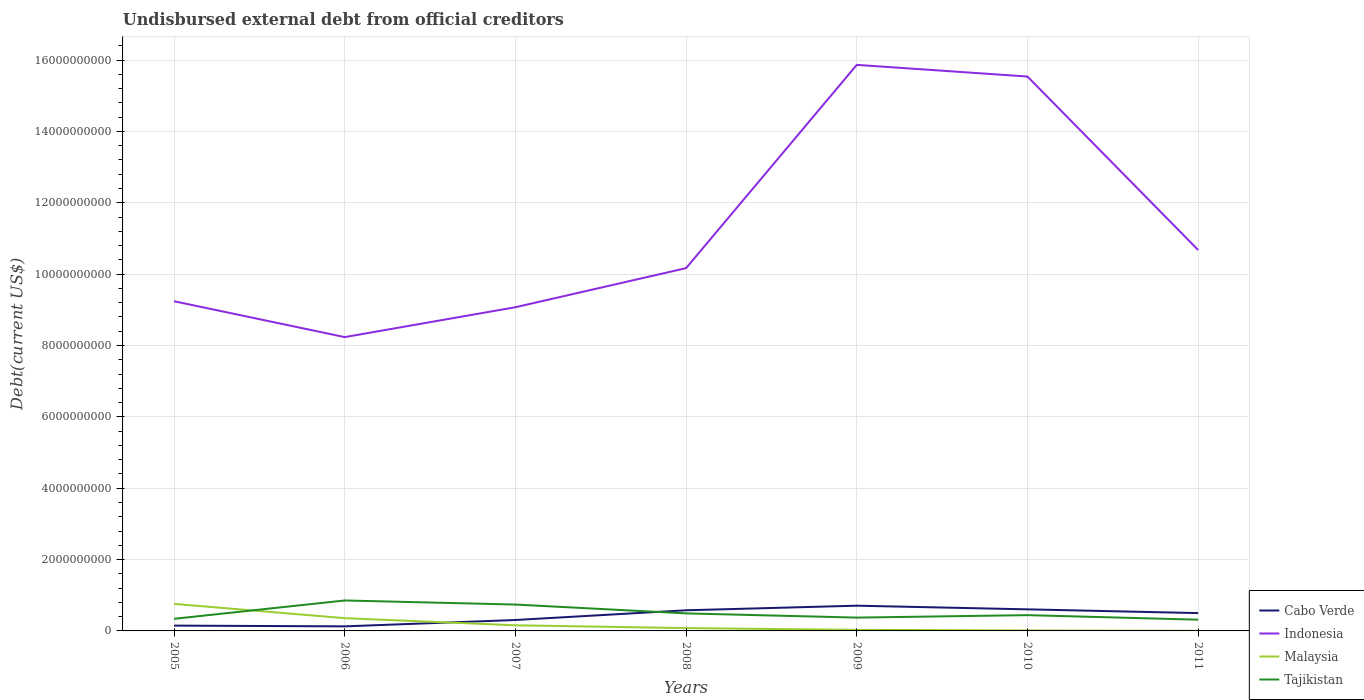How many different coloured lines are there?
Ensure brevity in your answer.  4. Does the line corresponding to Malaysia intersect with the line corresponding to Indonesia?
Offer a very short reply. No. Is the number of lines equal to the number of legend labels?
Provide a short and direct response. Yes. Across all years, what is the maximum total debt in Cabo Verde?
Offer a terse response. 1.28e+08. In which year was the total debt in Indonesia maximum?
Give a very brief answer. 2006. What is the total total debt in Indonesia in the graph?
Provide a succinct answer. -1.10e+09. What is the difference between the highest and the second highest total debt in Malaysia?
Your answer should be compact. 7.54e+08. What is the difference between two consecutive major ticks on the Y-axis?
Give a very brief answer. 2.00e+09. Where does the legend appear in the graph?
Keep it short and to the point. Bottom right. What is the title of the graph?
Your answer should be very brief. Undisbursed external debt from official creditors. Does "Senegal" appear as one of the legend labels in the graph?
Your answer should be compact. No. What is the label or title of the X-axis?
Offer a terse response. Years. What is the label or title of the Y-axis?
Your response must be concise. Debt(current US$). What is the Debt(current US$) in Cabo Verde in 2005?
Your response must be concise. 1.49e+08. What is the Debt(current US$) in Indonesia in 2005?
Your answer should be compact. 9.24e+09. What is the Debt(current US$) in Malaysia in 2005?
Your answer should be very brief. 7.57e+08. What is the Debt(current US$) in Tajikistan in 2005?
Your response must be concise. 3.39e+08. What is the Debt(current US$) in Cabo Verde in 2006?
Offer a terse response. 1.28e+08. What is the Debt(current US$) of Indonesia in 2006?
Offer a terse response. 8.23e+09. What is the Debt(current US$) of Malaysia in 2006?
Keep it short and to the point. 3.57e+08. What is the Debt(current US$) of Tajikistan in 2006?
Make the answer very short. 8.53e+08. What is the Debt(current US$) in Cabo Verde in 2007?
Offer a terse response. 3.06e+08. What is the Debt(current US$) of Indonesia in 2007?
Give a very brief answer. 9.07e+09. What is the Debt(current US$) of Malaysia in 2007?
Make the answer very short. 1.58e+08. What is the Debt(current US$) of Tajikistan in 2007?
Your response must be concise. 7.39e+08. What is the Debt(current US$) of Cabo Verde in 2008?
Your answer should be compact. 5.79e+08. What is the Debt(current US$) in Indonesia in 2008?
Your response must be concise. 1.02e+1. What is the Debt(current US$) of Malaysia in 2008?
Keep it short and to the point. 7.89e+07. What is the Debt(current US$) in Tajikistan in 2008?
Your answer should be very brief. 4.91e+08. What is the Debt(current US$) of Cabo Verde in 2009?
Give a very brief answer. 7.07e+08. What is the Debt(current US$) of Indonesia in 2009?
Provide a succinct answer. 1.59e+1. What is the Debt(current US$) in Malaysia in 2009?
Your answer should be compact. 3.03e+07. What is the Debt(current US$) of Tajikistan in 2009?
Give a very brief answer. 3.73e+08. What is the Debt(current US$) of Cabo Verde in 2010?
Make the answer very short. 6.05e+08. What is the Debt(current US$) in Indonesia in 2010?
Your answer should be very brief. 1.55e+1. What is the Debt(current US$) of Malaysia in 2010?
Your answer should be very brief. 1.37e+07. What is the Debt(current US$) of Tajikistan in 2010?
Give a very brief answer. 4.42e+08. What is the Debt(current US$) of Cabo Verde in 2011?
Keep it short and to the point. 5.00e+08. What is the Debt(current US$) of Indonesia in 2011?
Keep it short and to the point. 1.07e+1. What is the Debt(current US$) of Malaysia in 2011?
Your answer should be very brief. 3.48e+06. What is the Debt(current US$) of Tajikistan in 2011?
Give a very brief answer. 3.15e+08. Across all years, what is the maximum Debt(current US$) in Cabo Verde?
Your response must be concise. 7.07e+08. Across all years, what is the maximum Debt(current US$) of Indonesia?
Make the answer very short. 1.59e+1. Across all years, what is the maximum Debt(current US$) of Malaysia?
Make the answer very short. 7.57e+08. Across all years, what is the maximum Debt(current US$) in Tajikistan?
Offer a terse response. 8.53e+08. Across all years, what is the minimum Debt(current US$) of Cabo Verde?
Offer a very short reply. 1.28e+08. Across all years, what is the minimum Debt(current US$) of Indonesia?
Give a very brief answer. 8.23e+09. Across all years, what is the minimum Debt(current US$) of Malaysia?
Provide a short and direct response. 3.48e+06. Across all years, what is the minimum Debt(current US$) of Tajikistan?
Ensure brevity in your answer.  3.15e+08. What is the total Debt(current US$) in Cabo Verde in the graph?
Ensure brevity in your answer.  2.97e+09. What is the total Debt(current US$) in Indonesia in the graph?
Ensure brevity in your answer.  7.88e+1. What is the total Debt(current US$) of Malaysia in the graph?
Offer a very short reply. 1.40e+09. What is the total Debt(current US$) in Tajikistan in the graph?
Keep it short and to the point. 3.55e+09. What is the difference between the Debt(current US$) in Cabo Verde in 2005 and that in 2006?
Your answer should be compact. 2.10e+07. What is the difference between the Debt(current US$) of Indonesia in 2005 and that in 2006?
Offer a terse response. 1.01e+09. What is the difference between the Debt(current US$) of Malaysia in 2005 and that in 2006?
Offer a terse response. 4.00e+08. What is the difference between the Debt(current US$) in Tajikistan in 2005 and that in 2006?
Ensure brevity in your answer.  -5.14e+08. What is the difference between the Debt(current US$) in Cabo Verde in 2005 and that in 2007?
Your answer should be compact. -1.58e+08. What is the difference between the Debt(current US$) of Indonesia in 2005 and that in 2007?
Your answer should be very brief. 1.68e+08. What is the difference between the Debt(current US$) of Malaysia in 2005 and that in 2007?
Provide a short and direct response. 6.00e+08. What is the difference between the Debt(current US$) of Tajikistan in 2005 and that in 2007?
Provide a short and direct response. -4.00e+08. What is the difference between the Debt(current US$) of Cabo Verde in 2005 and that in 2008?
Your answer should be very brief. -4.30e+08. What is the difference between the Debt(current US$) of Indonesia in 2005 and that in 2008?
Provide a succinct answer. -9.28e+08. What is the difference between the Debt(current US$) of Malaysia in 2005 and that in 2008?
Keep it short and to the point. 6.79e+08. What is the difference between the Debt(current US$) of Tajikistan in 2005 and that in 2008?
Provide a succinct answer. -1.52e+08. What is the difference between the Debt(current US$) in Cabo Verde in 2005 and that in 2009?
Offer a very short reply. -5.58e+08. What is the difference between the Debt(current US$) of Indonesia in 2005 and that in 2009?
Make the answer very short. -6.62e+09. What is the difference between the Debt(current US$) in Malaysia in 2005 and that in 2009?
Give a very brief answer. 7.27e+08. What is the difference between the Debt(current US$) in Tajikistan in 2005 and that in 2009?
Keep it short and to the point. -3.41e+07. What is the difference between the Debt(current US$) in Cabo Verde in 2005 and that in 2010?
Make the answer very short. -4.56e+08. What is the difference between the Debt(current US$) of Indonesia in 2005 and that in 2010?
Provide a succinct answer. -6.30e+09. What is the difference between the Debt(current US$) of Malaysia in 2005 and that in 2010?
Ensure brevity in your answer.  7.44e+08. What is the difference between the Debt(current US$) of Tajikistan in 2005 and that in 2010?
Your answer should be compact. -1.03e+08. What is the difference between the Debt(current US$) of Cabo Verde in 2005 and that in 2011?
Give a very brief answer. -3.51e+08. What is the difference between the Debt(current US$) in Indonesia in 2005 and that in 2011?
Offer a very short reply. -1.44e+09. What is the difference between the Debt(current US$) of Malaysia in 2005 and that in 2011?
Your response must be concise. 7.54e+08. What is the difference between the Debt(current US$) of Tajikistan in 2005 and that in 2011?
Provide a short and direct response. 2.46e+07. What is the difference between the Debt(current US$) of Cabo Verde in 2006 and that in 2007?
Keep it short and to the point. -1.79e+08. What is the difference between the Debt(current US$) of Indonesia in 2006 and that in 2007?
Your answer should be compact. -8.38e+08. What is the difference between the Debt(current US$) of Malaysia in 2006 and that in 2007?
Provide a succinct answer. 2.00e+08. What is the difference between the Debt(current US$) in Tajikistan in 2006 and that in 2007?
Your answer should be compact. 1.14e+08. What is the difference between the Debt(current US$) in Cabo Verde in 2006 and that in 2008?
Make the answer very short. -4.51e+08. What is the difference between the Debt(current US$) in Indonesia in 2006 and that in 2008?
Provide a succinct answer. -1.93e+09. What is the difference between the Debt(current US$) in Malaysia in 2006 and that in 2008?
Give a very brief answer. 2.78e+08. What is the difference between the Debt(current US$) in Tajikistan in 2006 and that in 2008?
Provide a short and direct response. 3.62e+08. What is the difference between the Debt(current US$) in Cabo Verde in 2006 and that in 2009?
Provide a short and direct response. -5.79e+08. What is the difference between the Debt(current US$) in Indonesia in 2006 and that in 2009?
Provide a succinct answer. -7.63e+09. What is the difference between the Debt(current US$) of Malaysia in 2006 and that in 2009?
Your response must be concise. 3.27e+08. What is the difference between the Debt(current US$) in Tajikistan in 2006 and that in 2009?
Give a very brief answer. 4.80e+08. What is the difference between the Debt(current US$) of Cabo Verde in 2006 and that in 2010?
Keep it short and to the point. -4.77e+08. What is the difference between the Debt(current US$) in Indonesia in 2006 and that in 2010?
Make the answer very short. -7.30e+09. What is the difference between the Debt(current US$) in Malaysia in 2006 and that in 2010?
Offer a very short reply. 3.44e+08. What is the difference between the Debt(current US$) in Tajikistan in 2006 and that in 2010?
Give a very brief answer. 4.11e+08. What is the difference between the Debt(current US$) in Cabo Verde in 2006 and that in 2011?
Ensure brevity in your answer.  -3.72e+08. What is the difference between the Debt(current US$) of Indonesia in 2006 and that in 2011?
Provide a succinct answer. -2.44e+09. What is the difference between the Debt(current US$) in Malaysia in 2006 and that in 2011?
Ensure brevity in your answer.  3.54e+08. What is the difference between the Debt(current US$) of Tajikistan in 2006 and that in 2011?
Your answer should be compact. 5.39e+08. What is the difference between the Debt(current US$) in Cabo Verde in 2007 and that in 2008?
Offer a terse response. -2.72e+08. What is the difference between the Debt(current US$) in Indonesia in 2007 and that in 2008?
Provide a succinct answer. -1.10e+09. What is the difference between the Debt(current US$) in Malaysia in 2007 and that in 2008?
Ensure brevity in your answer.  7.87e+07. What is the difference between the Debt(current US$) in Tajikistan in 2007 and that in 2008?
Your response must be concise. 2.48e+08. What is the difference between the Debt(current US$) of Cabo Verde in 2007 and that in 2009?
Ensure brevity in your answer.  -4.01e+08. What is the difference between the Debt(current US$) of Indonesia in 2007 and that in 2009?
Ensure brevity in your answer.  -6.79e+09. What is the difference between the Debt(current US$) in Malaysia in 2007 and that in 2009?
Keep it short and to the point. 1.27e+08. What is the difference between the Debt(current US$) in Tajikistan in 2007 and that in 2009?
Offer a terse response. 3.66e+08. What is the difference between the Debt(current US$) in Cabo Verde in 2007 and that in 2010?
Provide a succinct answer. -2.98e+08. What is the difference between the Debt(current US$) in Indonesia in 2007 and that in 2010?
Offer a very short reply. -6.47e+09. What is the difference between the Debt(current US$) in Malaysia in 2007 and that in 2010?
Give a very brief answer. 1.44e+08. What is the difference between the Debt(current US$) in Tajikistan in 2007 and that in 2010?
Make the answer very short. 2.97e+08. What is the difference between the Debt(current US$) in Cabo Verde in 2007 and that in 2011?
Provide a succinct answer. -1.94e+08. What is the difference between the Debt(current US$) of Indonesia in 2007 and that in 2011?
Offer a terse response. -1.60e+09. What is the difference between the Debt(current US$) in Malaysia in 2007 and that in 2011?
Offer a very short reply. 1.54e+08. What is the difference between the Debt(current US$) of Tajikistan in 2007 and that in 2011?
Offer a terse response. 4.24e+08. What is the difference between the Debt(current US$) in Cabo Verde in 2008 and that in 2009?
Your response must be concise. -1.29e+08. What is the difference between the Debt(current US$) in Indonesia in 2008 and that in 2009?
Offer a terse response. -5.70e+09. What is the difference between the Debt(current US$) of Malaysia in 2008 and that in 2009?
Offer a terse response. 4.86e+07. What is the difference between the Debt(current US$) in Tajikistan in 2008 and that in 2009?
Your answer should be compact. 1.18e+08. What is the difference between the Debt(current US$) of Cabo Verde in 2008 and that in 2010?
Offer a terse response. -2.62e+07. What is the difference between the Debt(current US$) of Indonesia in 2008 and that in 2010?
Provide a short and direct response. -5.37e+09. What is the difference between the Debt(current US$) in Malaysia in 2008 and that in 2010?
Your answer should be very brief. 6.52e+07. What is the difference between the Debt(current US$) of Tajikistan in 2008 and that in 2010?
Your response must be concise. 4.91e+07. What is the difference between the Debt(current US$) in Cabo Verde in 2008 and that in 2011?
Provide a short and direct response. 7.88e+07. What is the difference between the Debt(current US$) in Indonesia in 2008 and that in 2011?
Make the answer very short. -5.10e+08. What is the difference between the Debt(current US$) in Malaysia in 2008 and that in 2011?
Ensure brevity in your answer.  7.54e+07. What is the difference between the Debt(current US$) of Tajikistan in 2008 and that in 2011?
Give a very brief answer. 1.77e+08. What is the difference between the Debt(current US$) in Cabo Verde in 2009 and that in 2010?
Your answer should be compact. 1.02e+08. What is the difference between the Debt(current US$) in Indonesia in 2009 and that in 2010?
Ensure brevity in your answer.  3.27e+08. What is the difference between the Debt(current US$) of Malaysia in 2009 and that in 2010?
Your answer should be very brief. 1.66e+07. What is the difference between the Debt(current US$) of Tajikistan in 2009 and that in 2010?
Your response must be concise. -6.88e+07. What is the difference between the Debt(current US$) in Cabo Verde in 2009 and that in 2011?
Your response must be concise. 2.07e+08. What is the difference between the Debt(current US$) in Indonesia in 2009 and that in 2011?
Provide a succinct answer. 5.19e+09. What is the difference between the Debt(current US$) of Malaysia in 2009 and that in 2011?
Provide a succinct answer. 2.68e+07. What is the difference between the Debt(current US$) of Tajikistan in 2009 and that in 2011?
Ensure brevity in your answer.  5.87e+07. What is the difference between the Debt(current US$) in Cabo Verde in 2010 and that in 2011?
Your response must be concise. 1.05e+08. What is the difference between the Debt(current US$) in Indonesia in 2010 and that in 2011?
Your response must be concise. 4.86e+09. What is the difference between the Debt(current US$) of Malaysia in 2010 and that in 2011?
Offer a terse response. 1.02e+07. What is the difference between the Debt(current US$) in Tajikistan in 2010 and that in 2011?
Make the answer very short. 1.27e+08. What is the difference between the Debt(current US$) of Cabo Verde in 2005 and the Debt(current US$) of Indonesia in 2006?
Your answer should be very brief. -8.09e+09. What is the difference between the Debt(current US$) of Cabo Verde in 2005 and the Debt(current US$) of Malaysia in 2006?
Provide a succinct answer. -2.09e+08. What is the difference between the Debt(current US$) in Cabo Verde in 2005 and the Debt(current US$) in Tajikistan in 2006?
Offer a terse response. -7.05e+08. What is the difference between the Debt(current US$) in Indonesia in 2005 and the Debt(current US$) in Malaysia in 2006?
Make the answer very short. 8.88e+09. What is the difference between the Debt(current US$) of Indonesia in 2005 and the Debt(current US$) of Tajikistan in 2006?
Ensure brevity in your answer.  8.39e+09. What is the difference between the Debt(current US$) in Malaysia in 2005 and the Debt(current US$) in Tajikistan in 2006?
Offer a terse response. -9.59e+07. What is the difference between the Debt(current US$) of Cabo Verde in 2005 and the Debt(current US$) of Indonesia in 2007?
Your response must be concise. -8.92e+09. What is the difference between the Debt(current US$) in Cabo Verde in 2005 and the Debt(current US$) in Malaysia in 2007?
Make the answer very short. -8.94e+06. What is the difference between the Debt(current US$) of Cabo Verde in 2005 and the Debt(current US$) of Tajikistan in 2007?
Provide a short and direct response. -5.90e+08. What is the difference between the Debt(current US$) of Indonesia in 2005 and the Debt(current US$) of Malaysia in 2007?
Offer a terse response. 9.08e+09. What is the difference between the Debt(current US$) in Indonesia in 2005 and the Debt(current US$) in Tajikistan in 2007?
Make the answer very short. 8.50e+09. What is the difference between the Debt(current US$) of Malaysia in 2005 and the Debt(current US$) of Tajikistan in 2007?
Your response must be concise. 1.83e+07. What is the difference between the Debt(current US$) of Cabo Verde in 2005 and the Debt(current US$) of Indonesia in 2008?
Offer a very short reply. -1.00e+1. What is the difference between the Debt(current US$) in Cabo Verde in 2005 and the Debt(current US$) in Malaysia in 2008?
Give a very brief answer. 6.98e+07. What is the difference between the Debt(current US$) of Cabo Verde in 2005 and the Debt(current US$) of Tajikistan in 2008?
Offer a very short reply. -3.43e+08. What is the difference between the Debt(current US$) in Indonesia in 2005 and the Debt(current US$) in Malaysia in 2008?
Provide a succinct answer. 9.16e+09. What is the difference between the Debt(current US$) in Indonesia in 2005 and the Debt(current US$) in Tajikistan in 2008?
Offer a terse response. 8.75e+09. What is the difference between the Debt(current US$) of Malaysia in 2005 and the Debt(current US$) of Tajikistan in 2008?
Provide a succinct answer. 2.66e+08. What is the difference between the Debt(current US$) of Cabo Verde in 2005 and the Debt(current US$) of Indonesia in 2009?
Give a very brief answer. -1.57e+1. What is the difference between the Debt(current US$) of Cabo Verde in 2005 and the Debt(current US$) of Malaysia in 2009?
Keep it short and to the point. 1.18e+08. What is the difference between the Debt(current US$) in Cabo Verde in 2005 and the Debt(current US$) in Tajikistan in 2009?
Keep it short and to the point. -2.25e+08. What is the difference between the Debt(current US$) of Indonesia in 2005 and the Debt(current US$) of Malaysia in 2009?
Keep it short and to the point. 9.21e+09. What is the difference between the Debt(current US$) in Indonesia in 2005 and the Debt(current US$) in Tajikistan in 2009?
Your response must be concise. 8.87e+09. What is the difference between the Debt(current US$) of Malaysia in 2005 and the Debt(current US$) of Tajikistan in 2009?
Provide a short and direct response. 3.84e+08. What is the difference between the Debt(current US$) in Cabo Verde in 2005 and the Debt(current US$) in Indonesia in 2010?
Ensure brevity in your answer.  -1.54e+1. What is the difference between the Debt(current US$) of Cabo Verde in 2005 and the Debt(current US$) of Malaysia in 2010?
Offer a very short reply. 1.35e+08. What is the difference between the Debt(current US$) in Cabo Verde in 2005 and the Debt(current US$) in Tajikistan in 2010?
Give a very brief answer. -2.94e+08. What is the difference between the Debt(current US$) of Indonesia in 2005 and the Debt(current US$) of Malaysia in 2010?
Offer a very short reply. 9.23e+09. What is the difference between the Debt(current US$) in Indonesia in 2005 and the Debt(current US$) in Tajikistan in 2010?
Your response must be concise. 8.80e+09. What is the difference between the Debt(current US$) of Malaysia in 2005 and the Debt(current US$) of Tajikistan in 2010?
Ensure brevity in your answer.  3.15e+08. What is the difference between the Debt(current US$) of Cabo Verde in 2005 and the Debt(current US$) of Indonesia in 2011?
Keep it short and to the point. -1.05e+1. What is the difference between the Debt(current US$) of Cabo Verde in 2005 and the Debt(current US$) of Malaysia in 2011?
Provide a succinct answer. 1.45e+08. What is the difference between the Debt(current US$) of Cabo Verde in 2005 and the Debt(current US$) of Tajikistan in 2011?
Your answer should be very brief. -1.66e+08. What is the difference between the Debt(current US$) of Indonesia in 2005 and the Debt(current US$) of Malaysia in 2011?
Your answer should be compact. 9.24e+09. What is the difference between the Debt(current US$) of Indonesia in 2005 and the Debt(current US$) of Tajikistan in 2011?
Ensure brevity in your answer.  8.93e+09. What is the difference between the Debt(current US$) in Malaysia in 2005 and the Debt(current US$) in Tajikistan in 2011?
Offer a very short reply. 4.43e+08. What is the difference between the Debt(current US$) of Cabo Verde in 2006 and the Debt(current US$) of Indonesia in 2007?
Give a very brief answer. -8.94e+09. What is the difference between the Debt(current US$) in Cabo Verde in 2006 and the Debt(current US$) in Malaysia in 2007?
Your response must be concise. -2.99e+07. What is the difference between the Debt(current US$) of Cabo Verde in 2006 and the Debt(current US$) of Tajikistan in 2007?
Make the answer very short. -6.11e+08. What is the difference between the Debt(current US$) in Indonesia in 2006 and the Debt(current US$) in Malaysia in 2007?
Keep it short and to the point. 8.08e+09. What is the difference between the Debt(current US$) in Indonesia in 2006 and the Debt(current US$) in Tajikistan in 2007?
Ensure brevity in your answer.  7.50e+09. What is the difference between the Debt(current US$) of Malaysia in 2006 and the Debt(current US$) of Tajikistan in 2007?
Give a very brief answer. -3.82e+08. What is the difference between the Debt(current US$) of Cabo Verde in 2006 and the Debt(current US$) of Indonesia in 2008?
Offer a very short reply. -1.00e+1. What is the difference between the Debt(current US$) in Cabo Verde in 2006 and the Debt(current US$) in Malaysia in 2008?
Your answer should be very brief. 4.88e+07. What is the difference between the Debt(current US$) in Cabo Verde in 2006 and the Debt(current US$) in Tajikistan in 2008?
Provide a short and direct response. -3.64e+08. What is the difference between the Debt(current US$) of Indonesia in 2006 and the Debt(current US$) of Malaysia in 2008?
Ensure brevity in your answer.  8.16e+09. What is the difference between the Debt(current US$) of Indonesia in 2006 and the Debt(current US$) of Tajikistan in 2008?
Make the answer very short. 7.74e+09. What is the difference between the Debt(current US$) in Malaysia in 2006 and the Debt(current US$) in Tajikistan in 2008?
Your response must be concise. -1.34e+08. What is the difference between the Debt(current US$) of Cabo Verde in 2006 and the Debt(current US$) of Indonesia in 2009?
Your response must be concise. -1.57e+1. What is the difference between the Debt(current US$) in Cabo Verde in 2006 and the Debt(current US$) in Malaysia in 2009?
Give a very brief answer. 9.74e+07. What is the difference between the Debt(current US$) of Cabo Verde in 2006 and the Debt(current US$) of Tajikistan in 2009?
Provide a succinct answer. -2.46e+08. What is the difference between the Debt(current US$) of Indonesia in 2006 and the Debt(current US$) of Malaysia in 2009?
Offer a terse response. 8.20e+09. What is the difference between the Debt(current US$) in Indonesia in 2006 and the Debt(current US$) in Tajikistan in 2009?
Offer a terse response. 7.86e+09. What is the difference between the Debt(current US$) of Malaysia in 2006 and the Debt(current US$) of Tajikistan in 2009?
Make the answer very short. -1.62e+07. What is the difference between the Debt(current US$) in Cabo Verde in 2006 and the Debt(current US$) in Indonesia in 2010?
Offer a very short reply. -1.54e+1. What is the difference between the Debt(current US$) in Cabo Verde in 2006 and the Debt(current US$) in Malaysia in 2010?
Your response must be concise. 1.14e+08. What is the difference between the Debt(current US$) in Cabo Verde in 2006 and the Debt(current US$) in Tajikistan in 2010?
Provide a succinct answer. -3.15e+08. What is the difference between the Debt(current US$) in Indonesia in 2006 and the Debt(current US$) in Malaysia in 2010?
Provide a succinct answer. 8.22e+09. What is the difference between the Debt(current US$) of Indonesia in 2006 and the Debt(current US$) of Tajikistan in 2010?
Offer a very short reply. 7.79e+09. What is the difference between the Debt(current US$) in Malaysia in 2006 and the Debt(current US$) in Tajikistan in 2010?
Provide a short and direct response. -8.50e+07. What is the difference between the Debt(current US$) in Cabo Verde in 2006 and the Debt(current US$) in Indonesia in 2011?
Your answer should be compact. -1.05e+1. What is the difference between the Debt(current US$) of Cabo Verde in 2006 and the Debt(current US$) of Malaysia in 2011?
Keep it short and to the point. 1.24e+08. What is the difference between the Debt(current US$) of Cabo Verde in 2006 and the Debt(current US$) of Tajikistan in 2011?
Make the answer very short. -1.87e+08. What is the difference between the Debt(current US$) of Indonesia in 2006 and the Debt(current US$) of Malaysia in 2011?
Ensure brevity in your answer.  8.23e+09. What is the difference between the Debt(current US$) of Indonesia in 2006 and the Debt(current US$) of Tajikistan in 2011?
Provide a short and direct response. 7.92e+09. What is the difference between the Debt(current US$) of Malaysia in 2006 and the Debt(current US$) of Tajikistan in 2011?
Keep it short and to the point. 4.25e+07. What is the difference between the Debt(current US$) in Cabo Verde in 2007 and the Debt(current US$) in Indonesia in 2008?
Make the answer very short. -9.86e+09. What is the difference between the Debt(current US$) of Cabo Verde in 2007 and the Debt(current US$) of Malaysia in 2008?
Your response must be concise. 2.27e+08. What is the difference between the Debt(current US$) of Cabo Verde in 2007 and the Debt(current US$) of Tajikistan in 2008?
Your answer should be very brief. -1.85e+08. What is the difference between the Debt(current US$) in Indonesia in 2007 and the Debt(current US$) in Malaysia in 2008?
Your answer should be compact. 8.99e+09. What is the difference between the Debt(current US$) in Indonesia in 2007 and the Debt(current US$) in Tajikistan in 2008?
Your answer should be compact. 8.58e+09. What is the difference between the Debt(current US$) of Malaysia in 2007 and the Debt(current US$) of Tajikistan in 2008?
Offer a terse response. -3.34e+08. What is the difference between the Debt(current US$) of Cabo Verde in 2007 and the Debt(current US$) of Indonesia in 2009?
Offer a terse response. -1.56e+1. What is the difference between the Debt(current US$) of Cabo Verde in 2007 and the Debt(current US$) of Malaysia in 2009?
Keep it short and to the point. 2.76e+08. What is the difference between the Debt(current US$) in Cabo Verde in 2007 and the Debt(current US$) in Tajikistan in 2009?
Offer a very short reply. -6.72e+07. What is the difference between the Debt(current US$) of Indonesia in 2007 and the Debt(current US$) of Malaysia in 2009?
Keep it short and to the point. 9.04e+09. What is the difference between the Debt(current US$) in Indonesia in 2007 and the Debt(current US$) in Tajikistan in 2009?
Keep it short and to the point. 8.70e+09. What is the difference between the Debt(current US$) of Malaysia in 2007 and the Debt(current US$) of Tajikistan in 2009?
Ensure brevity in your answer.  -2.16e+08. What is the difference between the Debt(current US$) of Cabo Verde in 2007 and the Debt(current US$) of Indonesia in 2010?
Offer a very short reply. -1.52e+1. What is the difference between the Debt(current US$) in Cabo Verde in 2007 and the Debt(current US$) in Malaysia in 2010?
Your answer should be compact. 2.93e+08. What is the difference between the Debt(current US$) of Cabo Verde in 2007 and the Debt(current US$) of Tajikistan in 2010?
Give a very brief answer. -1.36e+08. What is the difference between the Debt(current US$) in Indonesia in 2007 and the Debt(current US$) in Malaysia in 2010?
Provide a succinct answer. 9.06e+09. What is the difference between the Debt(current US$) in Indonesia in 2007 and the Debt(current US$) in Tajikistan in 2010?
Offer a very short reply. 8.63e+09. What is the difference between the Debt(current US$) of Malaysia in 2007 and the Debt(current US$) of Tajikistan in 2010?
Keep it short and to the point. -2.85e+08. What is the difference between the Debt(current US$) of Cabo Verde in 2007 and the Debt(current US$) of Indonesia in 2011?
Offer a terse response. -1.04e+1. What is the difference between the Debt(current US$) in Cabo Verde in 2007 and the Debt(current US$) in Malaysia in 2011?
Provide a short and direct response. 3.03e+08. What is the difference between the Debt(current US$) of Cabo Verde in 2007 and the Debt(current US$) of Tajikistan in 2011?
Ensure brevity in your answer.  -8.50e+06. What is the difference between the Debt(current US$) in Indonesia in 2007 and the Debt(current US$) in Malaysia in 2011?
Provide a succinct answer. 9.07e+09. What is the difference between the Debt(current US$) in Indonesia in 2007 and the Debt(current US$) in Tajikistan in 2011?
Your response must be concise. 8.76e+09. What is the difference between the Debt(current US$) of Malaysia in 2007 and the Debt(current US$) of Tajikistan in 2011?
Keep it short and to the point. -1.57e+08. What is the difference between the Debt(current US$) of Cabo Verde in 2008 and the Debt(current US$) of Indonesia in 2009?
Offer a terse response. -1.53e+1. What is the difference between the Debt(current US$) in Cabo Verde in 2008 and the Debt(current US$) in Malaysia in 2009?
Your response must be concise. 5.48e+08. What is the difference between the Debt(current US$) in Cabo Verde in 2008 and the Debt(current US$) in Tajikistan in 2009?
Your response must be concise. 2.05e+08. What is the difference between the Debt(current US$) in Indonesia in 2008 and the Debt(current US$) in Malaysia in 2009?
Your answer should be compact. 1.01e+1. What is the difference between the Debt(current US$) of Indonesia in 2008 and the Debt(current US$) of Tajikistan in 2009?
Keep it short and to the point. 9.79e+09. What is the difference between the Debt(current US$) in Malaysia in 2008 and the Debt(current US$) in Tajikistan in 2009?
Your response must be concise. -2.95e+08. What is the difference between the Debt(current US$) of Cabo Verde in 2008 and the Debt(current US$) of Indonesia in 2010?
Make the answer very short. -1.50e+1. What is the difference between the Debt(current US$) in Cabo Verde in 2008 and the Debt(current US$) in Malaysia in 2010?
Your response must be concise. 5.65e+08. What is the difference between the Debt(current US$) of Cabo Verde in 2008 and the Debt(current US$) of Tajikistan in 2010?
Make the answer very short. 1.36e+08. What is the difference between the Debt(current US$) of Indonesia in 2008 and the Debt(current US$) of Malaysia in 2010?
Give a very brief answer. 1.02e+1. What is the difference between the Debt(current US$) in Indonesia in 2008 and the Debt(current US$) in Tajikistan in 2010?
Provide a short and direct response. 9.73e+09. What is the difference between the Debt(current US$) of Malaysia in 2008 and the Debt(current US$) of Tajikistan in 2010?
Offer a terse response. -3.63e+08. What is the difference between the Debt(current US$) of Cabo Verde in 2008 and the Debt(current US$) of Indonesia in 2011?
Offer a terse response. -1.01e+1. What is the difference between the Debt(current US$) of Cabo Verde in 2008 and the Debt(current US$) of Malaysia in 2011?
Offer a terse response. 5.75e+08. What is the difference between the Debt(current US$) of Cabo Verde in 2008 and the Debt(current US$) of Tajikistan in 2011?
Provide a short and direct response. 2.64e+08. What is the difference between the Debt(current US$) in Indonesia in 2008 and the Debt(current US$) in Malaysia in 2011?
Provide a succinct answer. 1.02e+1. What is the difference between the Debt(current US$) in Indonesia in 2008 and the Debt(current US$) in Tajikistan in 2011?
Offer a terse response. 9.85e+09. What is the difference between the Debt(current US$) of Malaysia in 2008 and the Debt(current US$) of Tajikistan in 2011?
Your response must be concise. -2.36e+08. What is the difference between the Debt(current US$) of Cabo Verde in 2009 and the Debt(current US$) of Indonesia in 2010?
Your answer should be very brief. -1.48e+1. What is the difference between the Debt(current US$) in Cabo Verde in 2009 and the Debt(current US$) in Malaysia in 2010?
Give a very brief answer. 6.93e+08. What is the difference between the Debt(current US$) of Cabo Verde in 2009 and the Debt(current US$) of Tajikistan in 2010?
Offer a very short reply. 2.65e+08. What is the difference between the Debt(current US$) of Indonesia in 2009 and the Debt(current US$) of Malaysia in 2010?
Your answer should be very brief. 1.59e+1. What is the difference between the Debt(current US$) of Indonesia in 2009 and the Debt(current US$) of Tajikistan in 2010?
Offer a terse response. 1.54e+1. What is the difference between the Debt(current US$) of Malaysia in 2009 and the Debt(current US$) of Tajikistan in 2010?
Offer a terse response. -4.12e+08. What is the difference between the Debt(current US$) of Cabo Verde in 2009 and the Debt(current US$) of Indonesia in 2011?
Offer a very short reply. -9.97e+09. What is the difference between the Debt(current US$) of Cabo Verde in 2009 and the Debt(current US$) of Malaysia in 2011?
Make the answer very short. 7.04e+08. What is the difference between the Debt(current US$) in Cabo Verde in 2009 and the Debt(current US$) in Tajikistan in 2011?
Provide a short and direct response. 3.92e+08. What is the difference between the Debt(current US$) in Indonesia in 2009 and the Debt(current US$) in Malaysia in 2011?
Your answer should be very brief. 1.59e+1. What is the difference between the Debt(current US$) of Indonesia in 2009 and the Debt(current US$) of Tajikistan in 2011?
Give a very brief answer. 1.55e+1. What is the difference between the Debt(current US$) in Malaysia in 2009 and the Debt(current US$) in Tajikistan in 2011?
Make the answer very short. -2.84e+08. What is the difference between the Debt(current US$) in Cabo Verde in 2010 and the Debt(current US$) in Indonesia in 2011?
Your answer should be compact. -1.01e+1. What is the difference between the Debt(current US$) in Cabo Verde in 2010 and the Debt(current US$) in Malaysia in 2011?
Your answer should be compact. 6.01e+08. What is the difference between the Debt(current US$) in Cabo Verde in 2010 and the Debt(current US$) in Tajikistan in 2011?
Keep it short and to the point. 2.90e+08. What is the difference between the Debt(current US$) of Indonesia in 2010 and the Debt(current US$) of Malaysia in 2011?
Make the answer very short. 1.55e+1. What is the difference between the Debt(current US$) of Indonesia in 2010 and the Debt(current US$) of Tajikistan in 2011?
Your answer should be very brief. 1.52e+1. What is the difference between the Debt(current US$) of Malaysia in 2010 and the Debt(current US$) of Tajikistan in 2011?
Offer a very short reply. -3.01e+08. What is the average Debt(current US$) of Cabo Verde per year?
Provide a short and direct response. 4.25e+08. What is the average Debt(current US$) of Indonesia per year?
Provide a succinct answer. 1.13e+1. What is the average Debt(current US$) of Malaysia per year?
Make the answer very short. 2.00e+08. What is the average Debt(current US$) in Tajikistan per year?
Provide a short and direct response. 5.08e+08. In the year 2005, what is the difference between the Debt(current US$) of Cabo Verde and Debt(current US$) of Indonesia?
Ensure brevity in your answer.  -9.09e+09. In the year 2005, what is the difference between the Debt(current US$) in Cabo Verde and Debt(current US$) in Malaysia?
Make the answer very short. -6.09e+08. In the year 2005, what is the difference between the Debt(current US$) of Cabo Verde and Debt(current US$) of Tajikistan?
Ensure brevity in your answer.  -1.91e+08. In the year 2005, what is the difference between the Debt(current US$) in Indonesia and Debt(current US$) in Malaysia?
Give a very brief answer. 8.48e+09. In the year 2005, what is the difference between the Debt(current US$) of Indonesia and Debt(current US$) of Tajikistan?
Offer a terse response. 8.90e+09. In the year 2005, what is the difference between the Debt(current US$) of Malaysia and Debt(current US$) of Tajikistan?
Offer a terse response. 4.18e+08. In the year 2006, what is the difference between the Debt(current US$) in Cabo Verde and Debt(current US$) in Indonesia?
Offer a very short reply. -8.11e+09. In the year 2006, what is the difference between the Debt(current US$) in Cabo Verde and Debt(current US$) in Malaysia?
Offer a terse response. -2.30e+08. In the year 2006, what is the difference between the Debt(current US$) of Cabo Verde and Debt(current US$) of Tajikistan?
Keep it short and to the point. -7.26e+08. In the year 2006, what is the difference between the Debt(current US$) of Indonesia and Debt(current US$) of Malaysia?
Provide a short and direct response. 7.88e+09. In the year 2006, what is the difference between the Debt(current US$) of Indonesia and Debt(current US$) of Tajikistan?
Provide a short and direct response. 7.38e+09. In the year 2006, what is the difference between the Debt(current US$) of Malaysia and Debt(current US$) of Tajikistan?
Ensure brevity in your answer.  -4.96e+08. In the year 2007, what is the difference between the Debt(current US$) of Cabo Verde and Debt(current US$) of Indonesia?
Provide a short and direct response. -8.77e+09. In the year 2007, what is the difference between the Debt(current US$) of Cabo Verde and Debt(current US$) of Malaysia?
Offer a very short reply. 1.49e+08. In the year 2007, what is the difference between the Debt(current US$) in Cabo Verde and Debt(current US$) in Tajikistan?
Your answer should be compact. -4.33e+08. In the year 2007, what is the difference between the Debt(current US$) in Indonesia and Debt(current US$) in Malaysia?
Offer a terse response. 8.91e+09. In the year 2007, what is the difference between the Debt(current US$) of Indonesia and Debt(current US$) of Tajikistan?
Keep it short and to the point. 8.33e+09. In the year 2007, what is the difference between the Debt(current US$) of Malaysia and Debt(current US$) of Tajikistan?
Your response must be concise. -5.82e+08. In the year 2008, what is the difference between the Debt(current US$) of Cabo Verde and Debt(current US$) of Indonesia?
Make the answer very short. -9.59e+09. In the year 2008, what is the difference between the Debt(current US$) in Cabo Verde and Debt(current US$) in Malaysia?
Give a very brief answer. 5.00e+08. In the year 2008, what is the difference between the Debt(current US$) in Cabo Verde and Debt(current US$) in Tajikistan?
Offer a very short reply. 8.72e+07. In the year 2008, what is the difference between the Debt(current US$) in Indonesia and Debt(current US$) in Malaysia?
Ensure brevity in your answer.  1.01e+1. In the year 2008, what is the difference between the Debt(current US$) in Indonesia and Debt(current US$) in Tajikistan?
Offer a terse response. 9.68e+09. In the year 2008, what is the difference between the Debt(current US$) of Malaysia and Debt(current US$) of Tajikistan?
Ensure brevity in your answer.  -4.12e+08. In the year 2009, what is the difference between the Debt(current US$) in Cabo Verde and Debt(current US$) in Indonesia?
Make the answer very short. -1.52e+1. In the year 2009, what is the difference between the Debt(current US$) of Cabo Verde and Debt(current US$) of Malaysia?
Give a very brief answer. 6.77e+08. In the year 2009, what is the difference between the Debt(current US$) in Cabo Verde and Debt(current US$) in Tajikistan?
Your answer should be compact. 3.34e+08. In the year 2009, what is the difference between the Debt(current US$) in Indonesia and Debt(current US$) in Malaysia?
Ensure brevity in your answer.  1.58e+1. In the year 2009, what is the difference between the Debt(current US$) of Indonesia and Debt(current US$) of Tajikistan?
Offer a terse response. 1.55e+1. In the year 2009, what is the difference between the Debt(current US$) of Malaysia and Debt(current US$) of Tajikistan?
Give a very brief answer. -3.43e+08. In the year 2010, what is the difference between the Debt(current US$) in Cabo Verde and Debt(current US$) in Indonesia?
Provide a succinct answer. -1.49e+1. In the year 2010, what is the difference between the Debt(current US$) of Cabo Verde and Debt(current US$) of Malaysia?
Make the answer very short. 5.91e+08. In the year 2010, what is the difference between the Debt(current US$) of Cabo Verde and Debt(current US$) of Tajikistan?
Give a very brief answer. 1.63e+08. In the year 2010, what is the difference between the Debt(current US$) in Indonesia and Debt(current US$) in Malaysia?
Ensure brevity in your answer.  1.55e+1. In the year 2010, what is the difference between the Debt(current US$) in Indonesia and Debt(current US$) in Tajikistan?
Make the answer very short. 1.51e+1. In the year 2010, what is the difference between the Debt(current US$) in Malaysia and Debt(current US$) in Tajikistan?
Give a very brief answer. -4.29e+08. In the year 2011, what is the difference between the Debt(current US$) in Cabo Verde and Debt(current US$) in Indonesia?
Keep it short and to the point. -1.02e+1. In the year 2011, what is the difference between the Debt(current US$) of Cabo Verde and Debt(current US$) of Malaysia?
Your response must be concise. 4.96e+08. In the year 2011, what is the difference between the Debt(current US$) of Cabo Verde and Debt(current US$) of Tajikistan?
Give a very brief answer. 1.85e+08. In the year 2011, what is the difference between the Debt(current US$) in Indonesia and Debt(current US$) in Malaysia?
Keep it short and to the point. 1.07e+1. In the year 2011, what is the difference between the Debt(current US$) of Indonesia and Debt(current US$) of Tajikistan?
Offer a very short reply. 1.04e+1. In the year 2011, what is the difference between the Debt(current US$) in Malaysia and Debt(current US$) in Tajikistan?
Offer a terse response. -3.11e+08. What is the ratio of the Debt(current US$) in Cabo Verde in 2005 to that in 2006?
Your answer should be compact. 1.16. What is the ratio of the Debt(current US$) in Indonesia in 2005 to that in 2006?
Offer a very short reply. 1.12. What is the ratio of the Debt(current US$) in Malaysia in 2005 to that in 2006?
Keep it short and to the point. 2.12. What is the ratio of the Debt(current US$) in Tajikistan in 2005 to that in 2006?
Make the answer very short. 0.4. What is the ratio of the Debt(current US$) of Cabo Verde in 2005 to that in 2007?
Provide a succinct answer. 0.49. What is the ratio of the Debt(current US$) of Indonesia in 2005 to that in 2007?
Give a very brief answer. 1.02. What is the ratio of the Debt(current US$) of Malaysia in 2005 to that in 2007?
Offer a very short reply. 4.81. What is the ratio of the Debt(current US$) in Tajikistan in 2005 to that in 2007?
Keep it short and to the point. 0.46. What is the ratio of the Debt(current US$) in Cabo Verde in 2005 to that in 2008?
Your answer should be compact. 0.26. What is the ratio of the Debt(current US$) in Indonesia in 2005 to that in 2008?
Provide a succinct answer. 0.91. What is the ratio of the Debt(current US$) of Malaysia in 2005 to that in 2008?
Make the answer very short. 9.6. What is the ratio of the Debt(current US$) of Tajikistan in 2005 to that in 2008?
Ensure brevity in your answer.  0.69. What is the ratio of the Debt(current US$) in Cabo Verde in 2005 to that in 2009?
Keep it short and to the point. 0.21. What is the ratio of the Debt(current US$) of Indonesia in 2005 to that in 2009?
Give a very brief answer. 0.58. What is the ratio of the Debt(current US$) of Malaysia in 2005 to that in 2009?
Provide a short and direct response. 25.02. What is the ratio of the Debt(current US$) in Tajikistan in 2005 to that in 2009?
Your answer should be compact. 0.91. What is the ratio of the Debt(current US$) of Cabo Verde in 2005 to that in 2010?
Offer a terse response. 0.25. What is the ratio of the Debt(current US$) of Indonesia in 2005 to that in 2010?
Provide a succinct answer. 0.59. What is the ratio of the Debt(current US$) of Malaysia in 2005 to that in 2010?
Your answer should be compact. 55.35. What is the ratio of the Debt(current US$) in Tajikistan in 2005 to that in 2010?
Provide a short and direct response. 0.77. What is the ratio of the Debt(current US$) in Cabo Verde in 2005 to that in 2011?
Offer a terse response. 0.3. What is the ratio of the Debt(current US$) of Indonesia in 2005 to that in 2011?
Ensure brevity in your answer.  0.87. What is the ratio of the Debt(current US$) of Malaysia in 2005 to that in 2011?
Your response must be concise. 217.65. What is the ratio of the Debt(current US$) in Tajikistan in 2005 to that in 2011?
Your response must be concise. 1.08. What is the ratio of the Debt(current US$) of Cabo Verde in 2006 to that in 2007?
Your answer should be compact. 0.42. What is the ratio of the Debt(current US$) of Indonesia in 2006 to that in 2007?
Your answer should be very brief. 0.91. What is the ratio of the Debt(current US$) in Malaysia in 2006 to that in 2007?
Give a very brief answer. 2.27. What is the ratio of the Debt(current US$) in Tajikistan in 2006 to that in 2007?
Provide a short and direct response. 1.15. What is the ratio of the Debt(current US$) in Cabo Verde in 2006 to that in 2008?
Make the answer very short. 0.22. What is the ratio of the Debt(current US$) of Indonesia in 2006 to that in 2008?
Give a very brief answer. 0.81. What is the ratio of the Debt(current US$) of Malaysia in 2006 to that in 2008?
Provide a short and direct response. 4.53. What is the ratio of the Debt(current US$) of Tajikistan in 2006 to that in 2008?
Offer a very short reply. 1.74. What is the ratio of the Debt(current US$) in Cabo Verde in 2006 to that in 2009?
Ensure brevity in your answer.  0.18. What is the ratio of the Debt(current US$) of Indonesia in 2006 to that in 2009?
Your answer should be compact. 0.52. What is the ratio of the Debt(current US$) of Malaysia in 2006 to that in 2009?
Ensure brevity in your answer.  11.8. What is the ratio of the Debt(current US$) in Tajikistan in 2006 to that in 2009?
Offer a very short reply. 2.29. What is the ratio of the Debt(current US$) in Cabo Verde in 2006 to that in 2010?
Your answer should be very brief. 0.21. What is the ratio of the Debt(current US$) in Indonesia in 2006 to that in 2010?
Give a very brief answer. 0.53. What is the ratio of the Debt(current US$) in Malaysia in 2006 to that in 2010?
Make the answer very short. 26.1. What is the ratio of the Debt(current US$) in Tajikistan in 2006 to that in 2010?
Keep it short and to the point. 1.93. What is the ratio of the Debt(current US$) in Cabo Verde in 2006 to that in 2011?
Make the answer very short. 0.26. What is the ratio of the Debt(current US$) in Indonesia in 2006 to that in 2011?
Give a very brief answer. 0.77. What is the ratio of the Debt(current US$) in Malaysia in 2006 to that in 2011?
Provide a short and direct response. 102.65. What is the ratio of the Debt(current US$) in Tajikistan in 2006 to that in 2011?
Keep it short and to the point. 2.71. What is the ratio of the Debt(current US$) of Cabo Verde in 2007 to that in 2008?
Give a very brief answer. 0.53. What is the ratio of the Debt(current US$) in Indonesia in 2007 to that in 2008?
Provide a succinct answer. 0.89. What is the ratio of the Debt(current US$) of Malaysia in 2007 to that in 2008?
Your response must be concise. 2. What is the ratio of the Debt(current US$) in Tajikistan in 2007 to that in 2008?
Give a very brief answer. 1.5. What is the ratio of the Debt(current US$) of Cabo Verde in 2007 to that in 2009?
Your answer should be compact. 0.43. What is the ratio of the Debt(current US$) in Indonesia in 2007 to that in 2009?
Offer a very short reply. 0.57. What is the ratio of the Debt(current US$) in Malaysia in 2007 to that in 2009?
Make the answer very short. 5.21. What is the ratio of the Debt(current US$) in Tajikistan in 2007 to that in 2009?
Your answer should be very brief. 1.98. What is the ratio of the Debt(current US$) in Cabo Verde in 2007 to that in 2010?
Provide a succinct answer. 0.51. What is the ratio of the Debt(current US$) in Indonesia in 2007 to that in 2010?
Provide a succinct answer. 0.58. What is the ratio of the Debt(current US$) of Malaysia in 2007 to that in 2010?
Make the answer very short. 11.52. What is the ratio of the Debt(current US$) of Tajikistan in 2007 to that in 2010?
Offer a very short reply. 1.67. What is the ratio of the Debt(current US$) in Cabo Verde in 2007 to that in 2011?
Give a very brief answer. 0.61. What is the ratio of the Debt(current US$) in Indonesia in 2007 to that in 2011?
Your answer should be compact. 0.85. What is the ratio of the Debt(current US$) of Malaysia in 2007 to that in 2011?
Your response must be concise. 45.29. What is the ratio of the Debt(current US$) in Tajikistan in 2007 to that in 2011?
Offer a very short reply. 2.35. What is the ratio of the Debt(current US$) in Cabo Verde in 2008 to that in 2009?
Your response must be concise. 0.82. What is the ratio of the Debt(current US$) in Indonesia in 2008 to that in 2009?
Your response must be concise. 0.64. What is the ratio of the Debt(current US$) of Malaysia in 2008 to that in 2009?
Offer a terse response. 2.61. What is the ratio of the Debt(current US$) of Tajikistan in 2008 to that in 2009?
Your answer should be compact. 1.32. What is the ratio of the Debt(current US$) in Cabo Verde in 2008 to that in 2010?
Make the answer very short. 0.96. What is the ratio of the Debt(current US$) in Indonesia in 2008 to that in 2010?
Your answer should be very brief. 0.65. What is the ratio of the Debt(current US$) of Malaysia in 2008 to that in 2010?
Give a very brief answer. 5.77. What is the ratio of the Debt(current US$) in Tajikistan in 2008 to that in 2010?
Provide a succinct answer. 1.11. What is the ratio of the Debt(current US$) in Cabo Verde in 2008 to that in 2011?
Ensure brevity in your answer.  1.16. What is the ratio of the Debt(current US$) in Indonesia in 2008 to that in 2011?
Your response must be concise. 0.95. What is the ratio of the Debt(current US$) of Malaysia in 2008 to that in 2011?
Provide a succinct answer. 22.68. What is the ratio of the Debt(current US$) in Tajikistan in 2008 to that in 2011?
Your answer should be compact. 1.56. What is the ratio of the Debt(current US$) of Cabo Verde in 2009 to that in 2010?
Offer a very short reply. 1.17. What is the ratio of the Debt(current US$) of Malaysia in 2009 to that in 2010?
Your answer should be very brief. 2.21. What is the ratio of the Debt(current US$) of Tajikistan in 2009 to that in 2010?
Keep it short and to the point. 0.84. What is the ratio of the Debt(current US$) of Cabo Verde in 2009 to that in 2011?
Provide a short and direct response. 1.42. What is the ratio of the Debt(current US$) in Indonesia in 2009 to that in 2011?
Give a very brief answer. 1.49. What is the ratio of the Debt(current US$) of Malaysia in 2009 to that in 2011?
Your answer should be compact. 8.7. What is the ratio of the Debt(current US$) of Tajikistan in 2009 to that in 2011?
Ensure brevity in your answer.  1.19. What is the ratio of the Debt(current US$) in Cabo Verde in 2010 to that in 2011?
Provide a succinct answer. 1.21. What is the ratio of the Debt(current US$) of Indonesia in 2010 to that in 2011?
Make the answer very short. 1.46. What is the ratio of the Debt(current US$) in Malaysia in 2010 to that in 2011?
Your answer should be compact. 3.93. What is the ratio of the Debt(current US$) of Tajikistan in 2010 to that in 2011?
Make the answer very short. 1.41. What is the difference between the highest and the second highest Debt(current US$) in Cabo Verde?
Your answer should be compact. 1.02e+08. What is the difference between the highest and the second highest Debt(current US$) in Indonesia?
Provide a succinct answer. 3.27e+08. What is the difference between the highest and the second highest Debt(current US$) in Malaysia?
Your response must be concise. 4.00e+08. What is the difference between the highest and the second highest Debt(current US$) in Tajikistan?
Offer a very short reply. 1.14e+08. What is the difference between the highest and the lowest Debt(current US$) in Cabo Verde?
Keep it short and to the point. 5.79e+08. What is the difference between the highest and the lowest Debt(current US$) in Indonesia?
Keep it short and to the point. 7.63e+09. What is the difference between the highest and the lowest Debt(current US$) in Malaysia?
Provide a succinct answer. 7.54e+08. What is the difference between the highest and the lowest Debt(current US$) in Tajikistan?
Provide a succinct answer. 5.39e+08. 